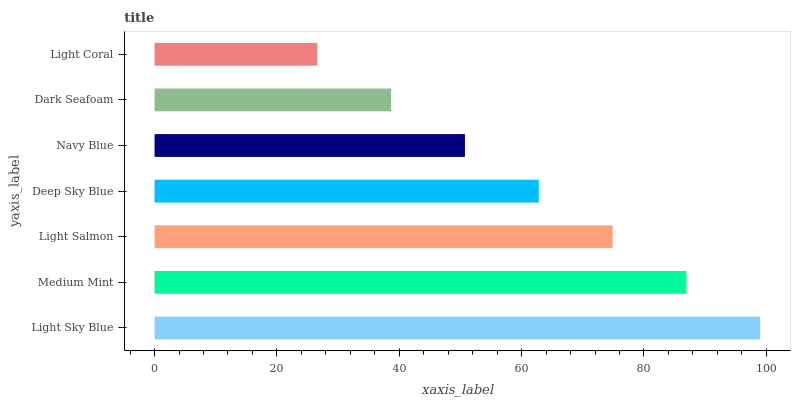Is Light Coral the minimum?
Answer yes or no. Yes. Is Light Sky Blue the maximum?
Answer yes or no. Yes. Is Medium Mint the minimum?
Answer yes or no. No. Is Medium Mint the maximum?
Answer yes or no. No. Is Light Sky Blue greater than Medium Mint?
Answer yes or no. Yes. Is Medium Mint less than Light Sky Blue?
Answer yes or no. Yes. Is Medium Mint greater than Light Sky Blue?
Answer yes or no. No. Is Light Sky Blue less than Medium Mint?
Answer yes or no. No. Is Deep Sky Blue the high median?
Answer yes or no. Yes. Is Deep Sky Blue the low median?
Answer yes or no. Yes. Is Light Sky Blue the high median?
Answer yes or no. No. Is Light Sky Blue the low median?
Answer yes or no. No. 